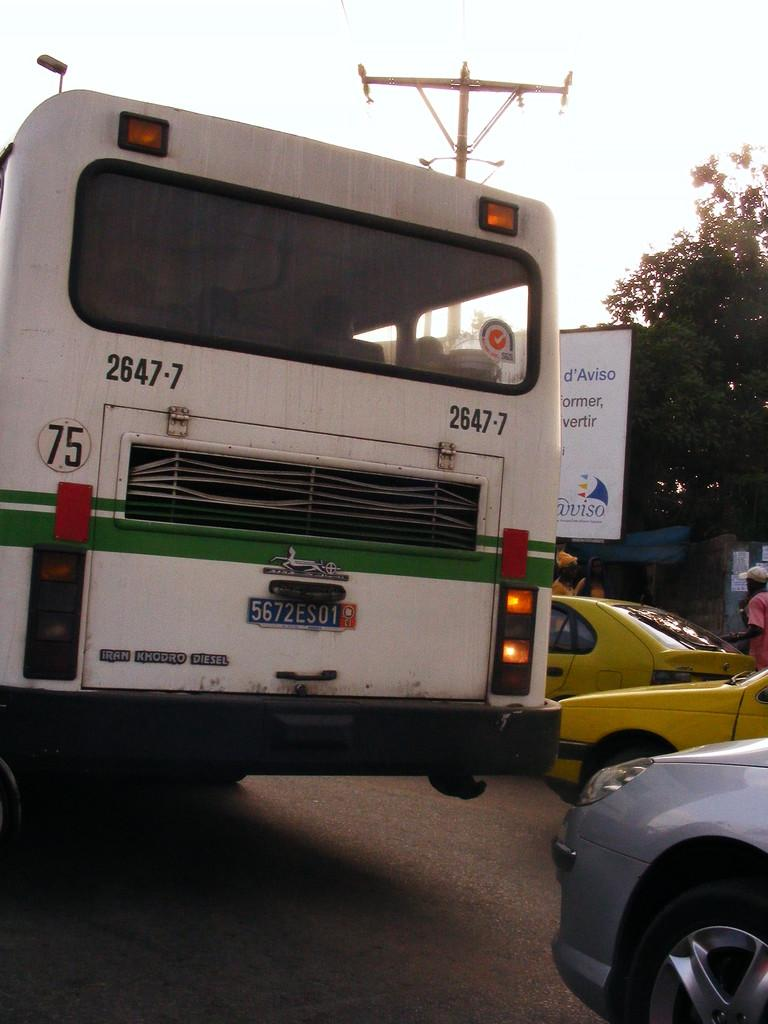<image>
Present a compact description of the photo's key features. A large white bus with green stripes is in traffic and has the number 75 on it. 